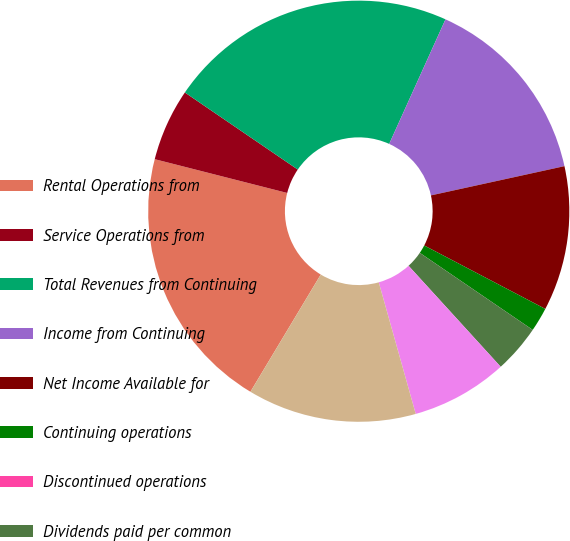<chart> <loc_0><loc_0><loc_500><loc_500><pie_chart><fcel>Rental Operations from<fcel>Service Operations from<fcel>Total Revenues from Continuing<fcel>Income from Continuing<fcel>Net Income Available for<fcel>Continuing operations<fcel>Discontinued operations<fcel>Dividends paid per common<fcel>Weighted average common shares<fcel>Weighted average common and<nl><fcel>20.37%<fcel>5.56%<fcel>22.22%<fcel>14.81%<fcel>11.11%<fcel>1.85%<fcel>0.0%<fcel>3.7%<fcel>7.41%<fcel>12.96%<nl></chart> 